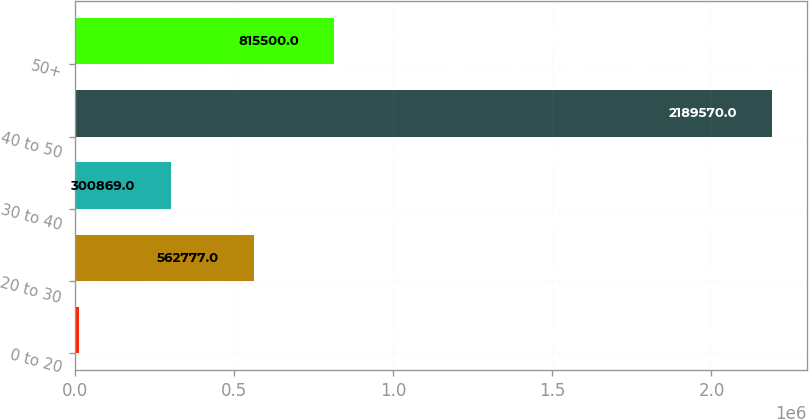Convert chart to OTSL. <chart><loc_0><loc_0><loc_500><loc_500><bar_chart><fcel>0 to 20<fcel>20 to 30<fcel>30 to 40<fcel>40 to 50<fcel>50+<nl><fcel>12150<fcel>562777<fcel>300869<fcel>2.18957e+06<fcel>815500<nl></chart> 